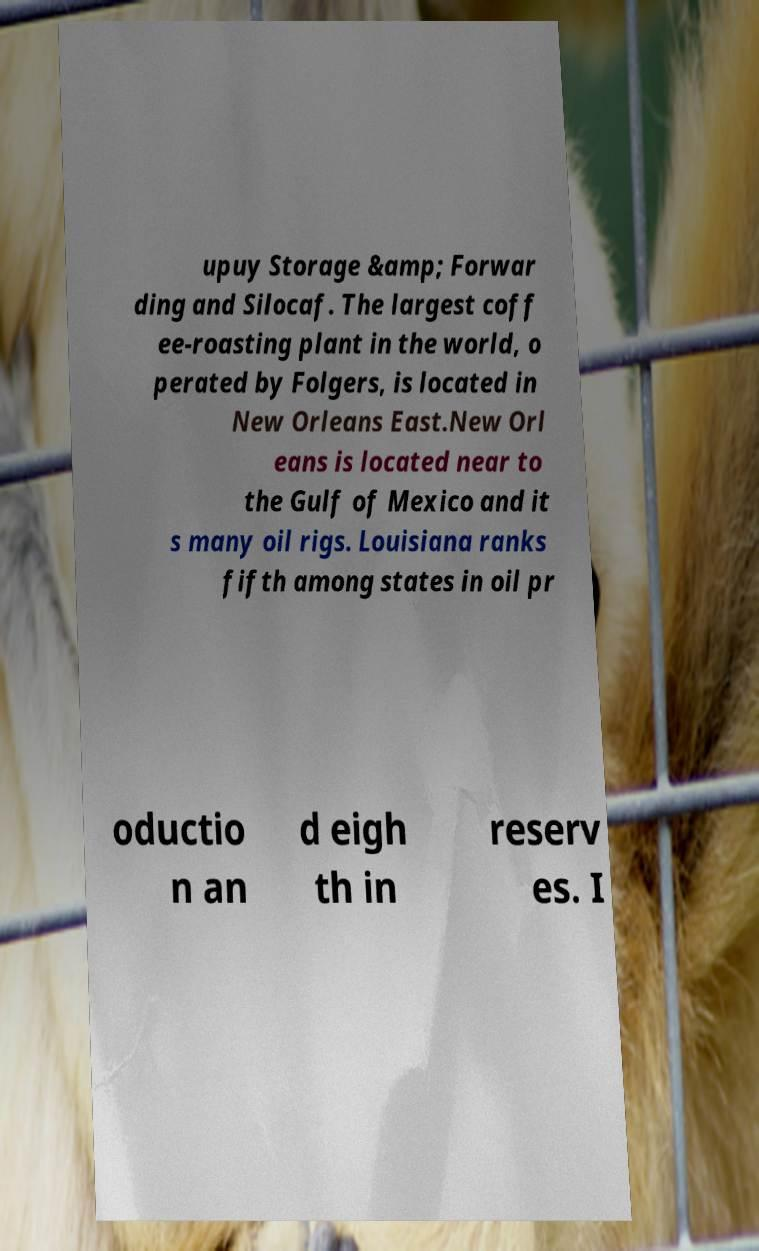Could you extract and type out the text from this image? upuy Storage &amp; Forwar ding and Silocaf. The largest coff ee-roasting plant in the world, o perated by Folgers, is located in New Orleans East.New Orl eans is located near to the Gulf of Mexico and it s many oil rigs. Louisiana ranks fifth among states in oil pr oductio n an d eigh th in reserv es. I 